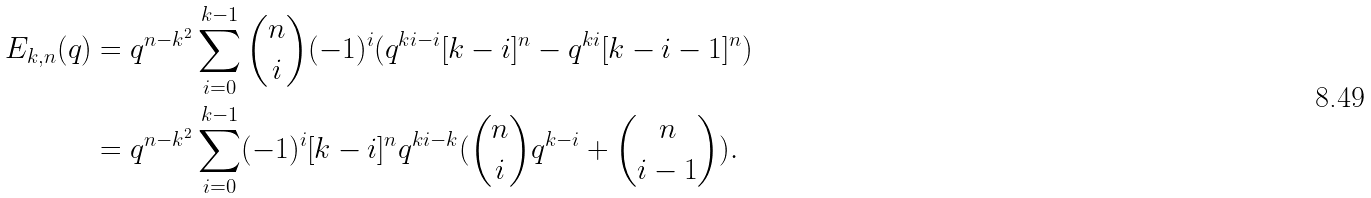Convert formula to latex. <formula><loc_0><loc_0><loc_500><loc_500>E _ { k , n } ( q ) & = q ^ { n - k ^ { 2 } } \sum _ { i = 0 } ^ { k - 1 } { n \choose i } ( - 1 ) ^ { i } ( q ^ { k i - i } [ k - i ] ^ { n } - q ^ { k i } [ k - i - 1 ] ^ { n } ) \\ & = q ^ { n - k ^ { 2 } } \sum _ { i = 0 } ^ { k - 1 } ( - 1 ) ^ { i } [ k - i ] ^ { n } q ^ { k i - k } ( { n \choose i } q ^ { k - i } + { n \choose i - 1 } ) .</formula> 